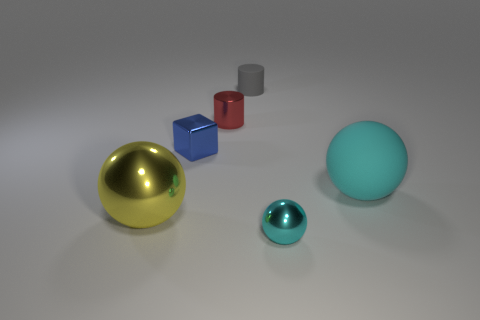Add 1 large yellow metal things. How many objects exist? 7 Subtract all cylinders. How many objects are left? 4 Add 6 tiny blue objects. How many tiny blue objects are left? 7 Add 3 big purple matte cubes. How many big purple matte cubes exist? 3 Subtract 0 yellow cubes. How many objects are left? 6 Subtract all tiny gray cylinders. Subtract all small green metal cubes. How many objects are left? 5 